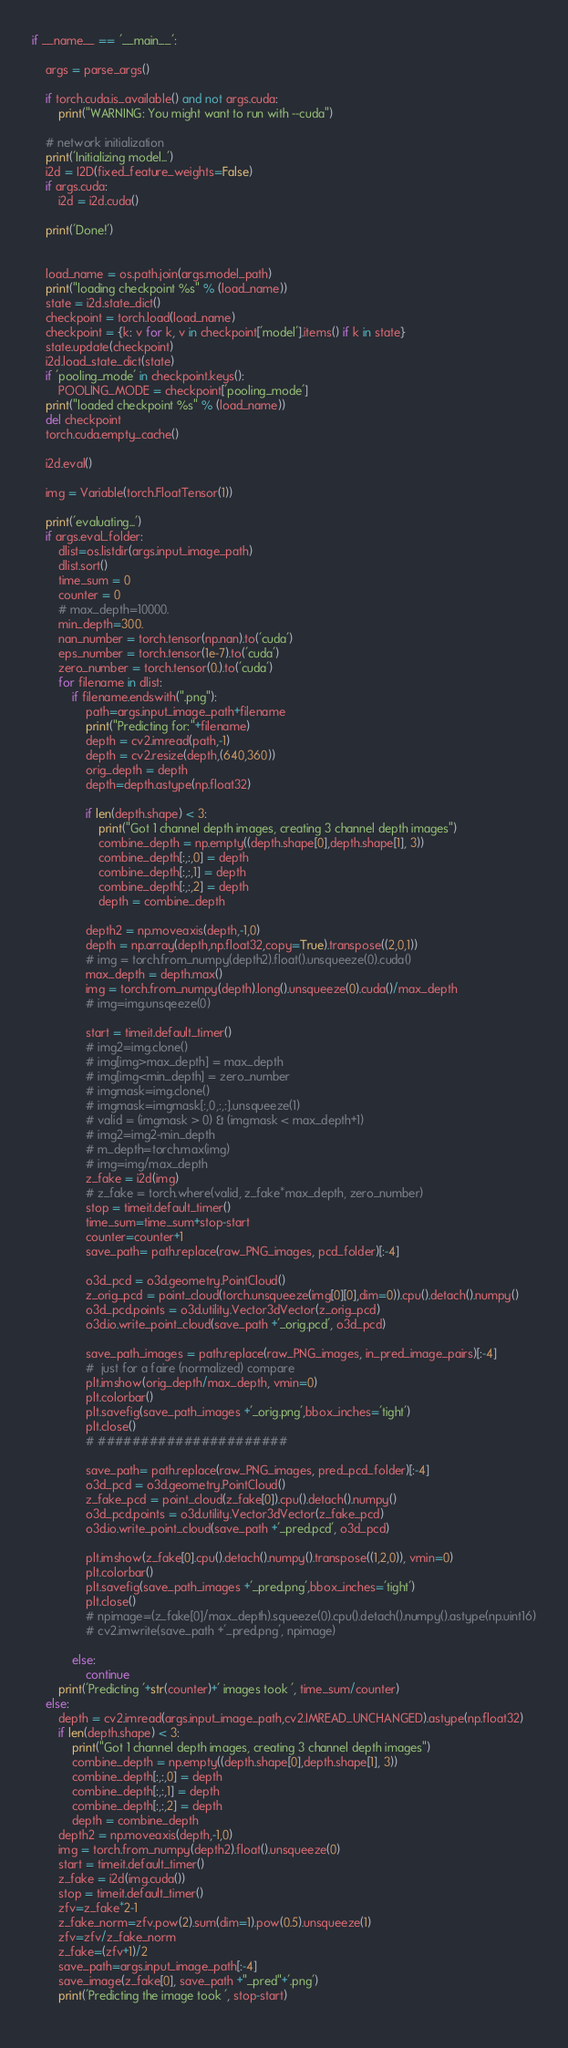<code> <loc_0><loc_0><loc_500><loc_500><_Python_>
if __name__ == '__main__':

    args = parse_args()

    if torch.cuda.is_available() and not args.cuda:
        print("WARNING: You might want to run with --cuda")
    
    # network initialization
    print('Initializing model...')
    i2d = I2D(fixed_feature_weights=False)
    if args.cuda:
        i2d = i2d.cuda()
        
    print('Done!')
    
    
    load_name = os.path.join(args.model_path)
    print("loading checkpoint %s" % (load_name))
    state = i2d.state_dict()
    checkpoint = torch.load(load_name)
    checkpoint = {k: v for k, v in checkpoint['model'].items() if k in state}
    state.update(checkpoint)
    i2d.load_state_dict(state)
    if 'pooling_mode' in checkpoint.keys():
        POOLING_MODE = checkpoint['pooling_mode']
    print("loaded checkpoint %s" % (load_name))
    del checkpoint
    torch.cuda.empty_cache()

    i2d.eval()

    img = Variable(torch.FloatTensor(1))

    print('evaluating...')
    if args.eval_folder:
        dlist=os.listdir(args.input_image_path)
        dlist.sort()
        time_sum = 0
        counter = 0
        # max_depth=10000.
        min_depth=300.
        nan_number = torch.tensor(np.nan).to('cuda')
        eps_number = torch.tensor(1e-7).to('cuda')
        zero_number = torch.tensor(0.).to('cuda')
        for filename in dlist:
            if filename.endswith(".png"):
                path=args.input_image_path+filename
                print("Predicting for:"+filename)
                depth = cv2.imread(path,-1)
                depth = cv2.resize(depth,(640,360))
                orig_depth = depth
                depth=depth.astype(np.float32)
                
                if len(depth.shape) < 3:
                    print("Got 1 channel depth images, creating 3 channel depth images")
                    combine_depth = np.empty((depth.shape[0],depth.shape[1], 3))
                    combine_depth[:,:,0] = depth
                    combine_depth[:,:,1] = depth
                    combine_depth[:,:,2] = depth
                    depth = combine_depth

                depth2 = np.moveaxis(depth,-1,0)
                depth = np.array(depth,np.float32,copy=True).transpose((2,0,1)) 
                # img = torch.from_numpy(depth2).float().unsqueeze(0).cuda()
                max_depth = depth.max()
                img = torch.from_numpy(depth).long().unsqueeze(0).cuda()/max_depth
                # img=img.unsqeeze(0)
                
                start = timeit.default_timer()
                # img2=img.clone()
                # img[img>max_depth] = max_depth
                # img[img<min_depth] = zero_number
                # imgmask=img.clone()
                # imgmask=imgmask[:,0,:,:].unsqueeze(1)
                # valid = (imgmask > 0) & (imgmask < max_depth+1)
                # img2=img2-min_depth
                # m_depth=torch.max(img)
                # img=img/max_depth                 
                z_fake = i2d(img)
                # z_fake = torch.where(valid, z_fake*max_depth, zero_number)
                stop = timeit.default_timer()
                time_sum=time_sum+stop-start
                counter=counter+1
                save_path= path.replace(raw_PNG_images, pcd_folder)[:-4]

                o3d_pcd = o3d.geometry.PointCloud()
                z_orig_pcd = point_cloud(torch.unsqueeze(img[0][0],dim=0)).cpu().detach().numpy()
                o3d_pcd.points = o3d.utility.Vector3dVector(z_orig_pcd)
                o3d.io.write_point_cloud(save_path +'_orig.pcd', o3d_pcd)
                
                save_path_images = path.replace(raw_PNG_images, in_pred_image_pairs)[:-4]
                #  just for a faire (normalized) compare
                plt.imshow(orig_depth/max_depth, vmin=0)
                plt.colorbar()
                plt.savefig(save_path_images +'_orig.png',bbox_inches='tight')
                plt.close()
                # ######################

                save_path= path.replace(raw_PNG_images, pred_pcd_folder)[:-4]
                o3d_pcd = o3d.geometry.PointCloud()
                z_fake_pcd = point_cloud(z_fake[0]).cpu().detach().numpy()
                o3d_pcd.points = o3d.utility.Vector3dVector(z_fake_pcd)
                o3d.io.write_point_cloud(save_path +'_pred.pcd', o3d_pcd)

                plt.imshow(z_fake[0].cpu().detach().numpy().transpose((1,2,0)), vmin=0)
                plt.colorbar()
                plt.savefig(save_path_images +'_pred.png',bbox_inches='tight')
                plt.close()
                # npimage=(z_fake[0]/max_depth).squeeze(0).cpu().detach().numpy().astype(np.uint16)
                # cv2.imwrite(save_path +'_pred.png', npimage)

            else:
                continue
        print('Predicting '+str(counter)+' images took ', time_sum/counter)  
    else:
        depth = cv2.imread(args.input_image_path,cv2.IMREAD_UNCHANGED).astype(np.float32)
        if len(depth.shape) < 3:
            print("Got 1 channel depth images, creating 3 channel depth images")
            combine_depth = np.empty((depth.shape[0],depth.shape[1], 3))
            combine_depth[:,:,0] = depth
            combine_depth[:,:,1] = depth
            combine_depth[:,:,2] = depth
            depth = combine_depth
        depth2 = np.moveaxis(depth,-1,0)
        img = torch.from_numpy(depth2).float().unsqueeze(0)
        start = timeit.default_timer()
        z_fake = i2d(img.cuda())
        stop = timeit.default_timer()
        zfv=z_fake*2-1
        z_fake_norm=zfv.pow(2).sum(dim=1).pow(0.5).unsqueeze(1)
        zfv=zfv/z_fake_norm
        z_fake=(zfv+1)/2
        save_path=args.input_image_path[:-4]
        save_image(z_fake[0], save_path +"_pred"+'.png')
        print('Predicting the image took ', stop-start)
    

</code> 